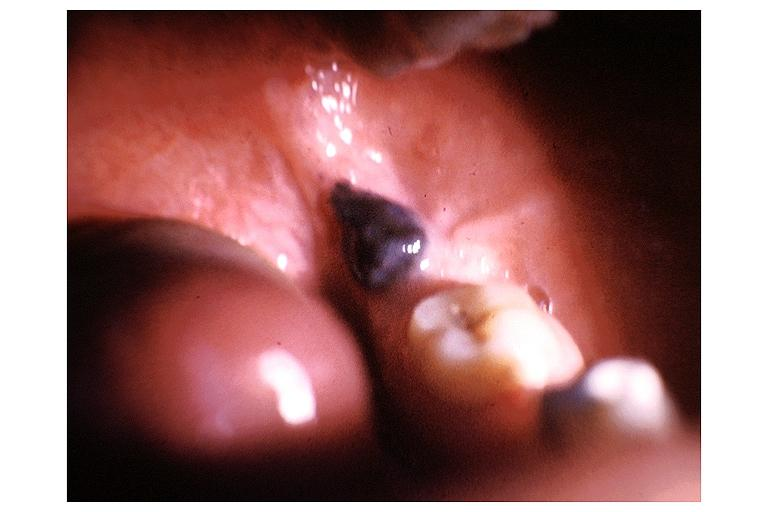where is this?
Answer the question using a single word or phrase. Oral 